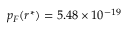Convert formula to latex. <formula><loc_0><loc_0><loc_500><loc_500>p _ { F } ( r ^ { * } ) = 5 . 4 8 \times 1 0 ^ { - 1 9 }</formula> 